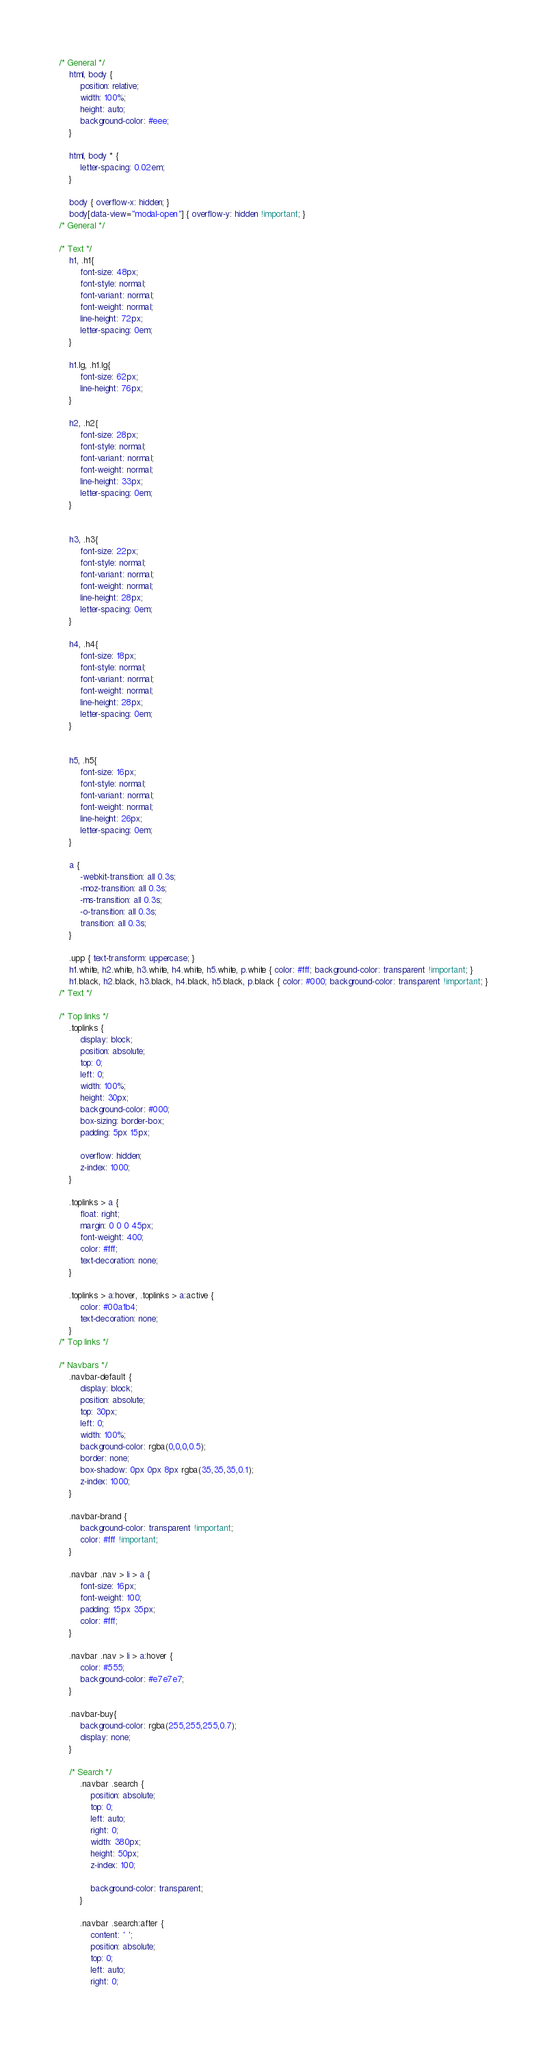<code> <loc_0><loc_0><loc_500><loc_500><_CSS_>/* General */
	html, body {
		position: relative;
		width: 100%;
		height: auto;
		background-color: #eee;
	}

	html, body * {
		letter-spacing: 0.02em;
	}

	body { overflow-x: hidden; }
	body[data-view="modal-open"] { overflow-y: hidden !important; }
/* General */

/* Text */
	h1, .h1{
		font-size: 48px;
		font-style: normal;
		font-variant: normal;
		font-weight: normal;
		line-height: 72px;
		letter-spacing: 0em;
	}

	h1.lg, .h1.lg{
		font-size: 62px;
		line-height: 76px;
	}

	h2, .h2{
		font-size: 28px;
		font-style: normal;
		font-variant: normal;
		font-weight: normal;
		line-height: 33px;
		letter-spacing: 0em;
	}
	

	h3, .h3{
		font-size: 22px;
		font-style: normal;
		font-variant: normal;
		font-weight: normal;
		line-height: 28px;
		letter-spacing: 0em;
	}

	h4, .h4{
		font-size: 18px;
		font-style: normal;
		font-variant: normal;
		font-weight: normal;
		line-height: 28px;
		letter-spacing: 0em;
	}

	
	h5, .h5{
		font-size: 16px;
		font-style: normal;
		font-variant: normal;
		font-weight: normal;
		line-height: 26px;
		letter-spacing: 0em;
	}

	a {
		-webkit-transition: all 0.3s;
		-moz-transition: all 0.3s;
		-ms-transition: all 0.3s;
		-o-transition: all 0.3s;
		transition: all 0.3s;
	}

	.upp { text-transform: uppercase; }
	h1.white, h2.white, h3.white, h4.white, h5.white, p.white { color: #fff; background-color: transparent !important; }
	h1.black, h2.black, h3.black, h4.black, h5.black, p.black { color: #000; background-color: transparent !important; }
/* Text */

/* Top links */
	.toplinks {
		display: block;
		position: absolute;
		top: 0;
		left: 0;
		width: 100%;
		height: 30px;
		background-color: #000;
		box-sizing: border-box;
		padding: 5px 15px;

		overflow: hidden;
		z-index: 1000;
	}

	.toplinks > a {
		float: right;
		margin: 0 0 0 45px;
		font-weight: 400;
		color: #fff;
		text-decoration: none;
	}

	.toplinks > a:hover, .toplinks > a:active {
		color: #00a1b4;
		text-decoration: none;
	}
/* Top links */

/* Navbars */
	.navbar-default {
		display: block;
		position: absolute;
		top: 30px;
		left: 0;
		width: 100%;
	    background-color: rgba(0,0,0,0.5);
	    border: none;
	    box-shadow: 0px 0px 8px rgba(35,35,35,0.1);
	    z-index: 1000;
	}

	.navbar-brand {
		background-color: transparent !important;
		color: #fff !important;
	}

	.navbar .nav > li > a {
		font-size: 16px;
		font-weight: 100;
		padding: 15px 35px;
		color: #fff;
	}

	.navbar .nav > li > a:hover {
		color: #555;
    	background-color: #e7e7e7;
	}

	.navbar-buy{
		background-color: rgba(255,255,255,0.7);
		display: none;
	}

	/* Search */
		.navbar .search {
			position: absolute;
			top: 0;
			left: auto;
			right: 0;
			width: 380px;
			height: 50px;
			z-index: 100;

			background-color: transparent;
		}

		.navbar .search:after {
			content: ' ';
			position: absolute;
			top: 0;
			left: auto;
			right: 0;</code> 